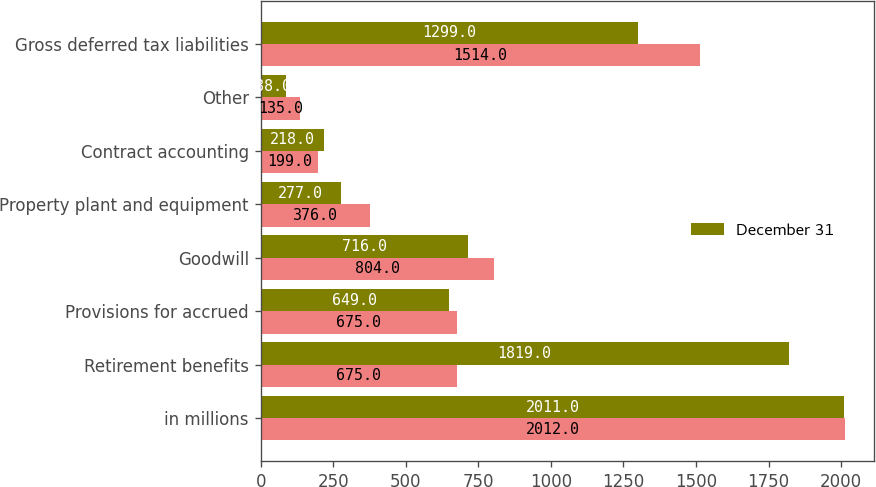Convert chart. <chart><loc_0><loc_0><loc_500><loc_500><stacked_bar_chart><ecel><fcel>in millions<fcel>Retirement benefits<fcel>Provisions for accrued<fcel>Goodwill<fcel>Property plant and equipment<fcel>Contract accounting<fcel>Other<fcel>Gross deferred tax liabilities<nl><fcel>nan<fcel>2012<fcel>675<fcel>675<fcel>804<fcel>376<fcel>199<fcel>135<fcel>1514<nl><fcel>December 31<fcel>2011<fcel>1819<fcel>649<fcel>716<fcel>277<fcel>218<fcel>88<fcel>1299<nl></chart> 